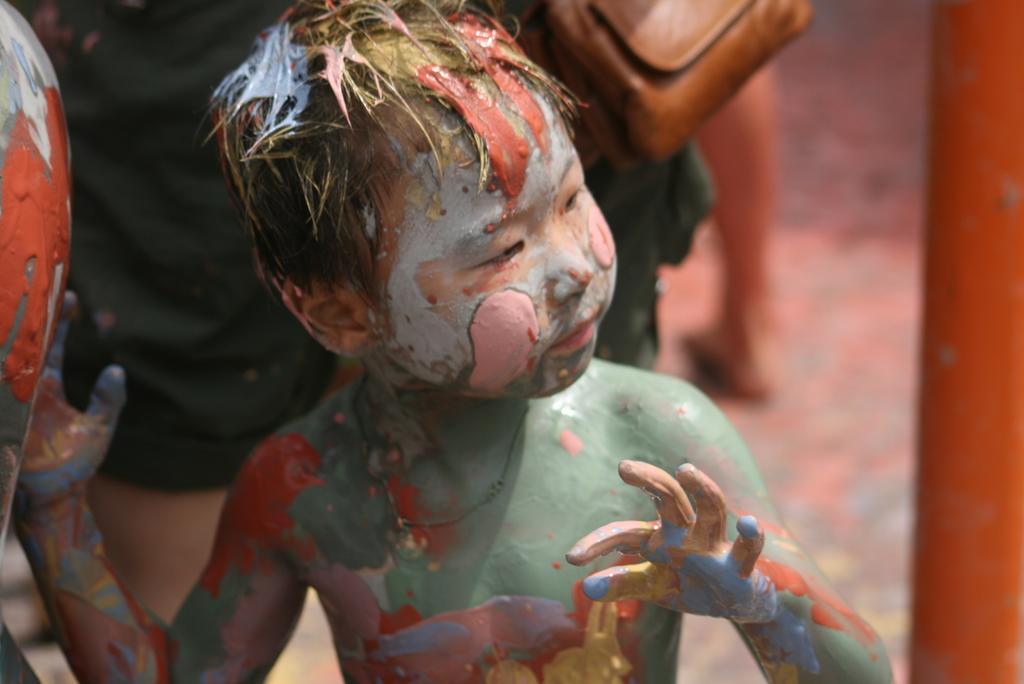Describe this image in one or two sentences. In this image we can see a boy where is he completely color with paints. In the background the image is in a blur. 